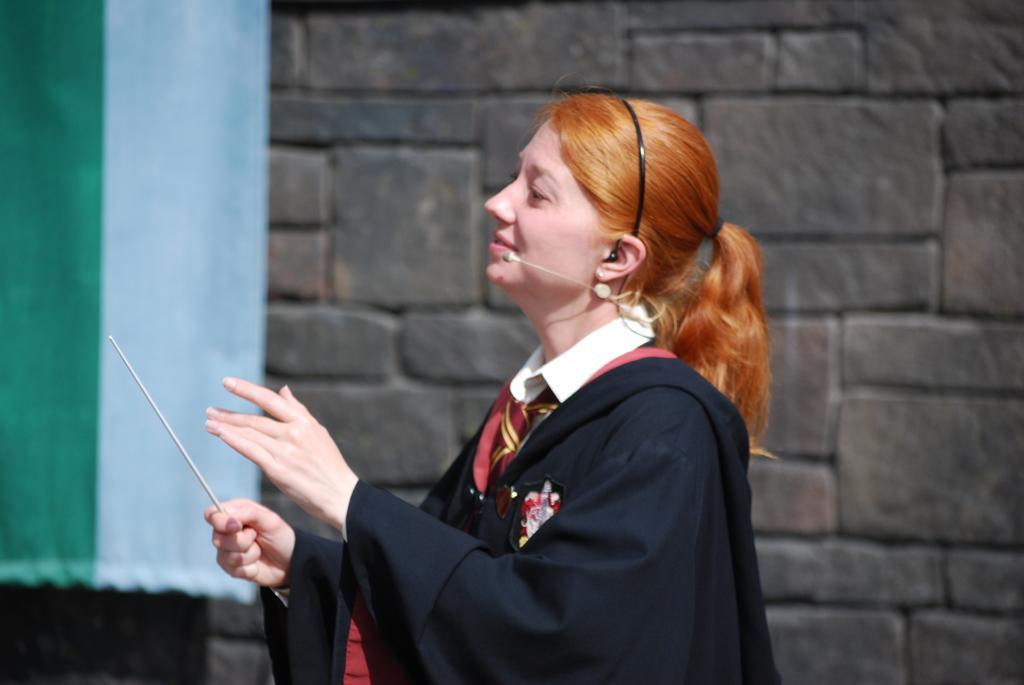In one or two sentences, can you explain what this image depicts? In the image in the center we can see one woman standing and holding stick. And she is smiling,which we can see on her face. In the background we can see curtain and wall. 